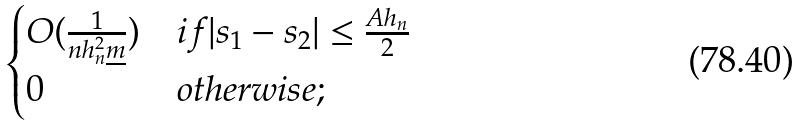Convert formula to latex. <formula><loc_0><loc_0><loc_500><loc_500>\begin{cases} O ( \frac { 1 } { n h _ { n } ^ { 2 } \underline { m } } ) & i f | s _ { 1 } - s _ { 2 } | \leq \frac { A h _ { n } } { 2 } \\ 0 & o t h e r w i s e ; \end{cases}</formula> 